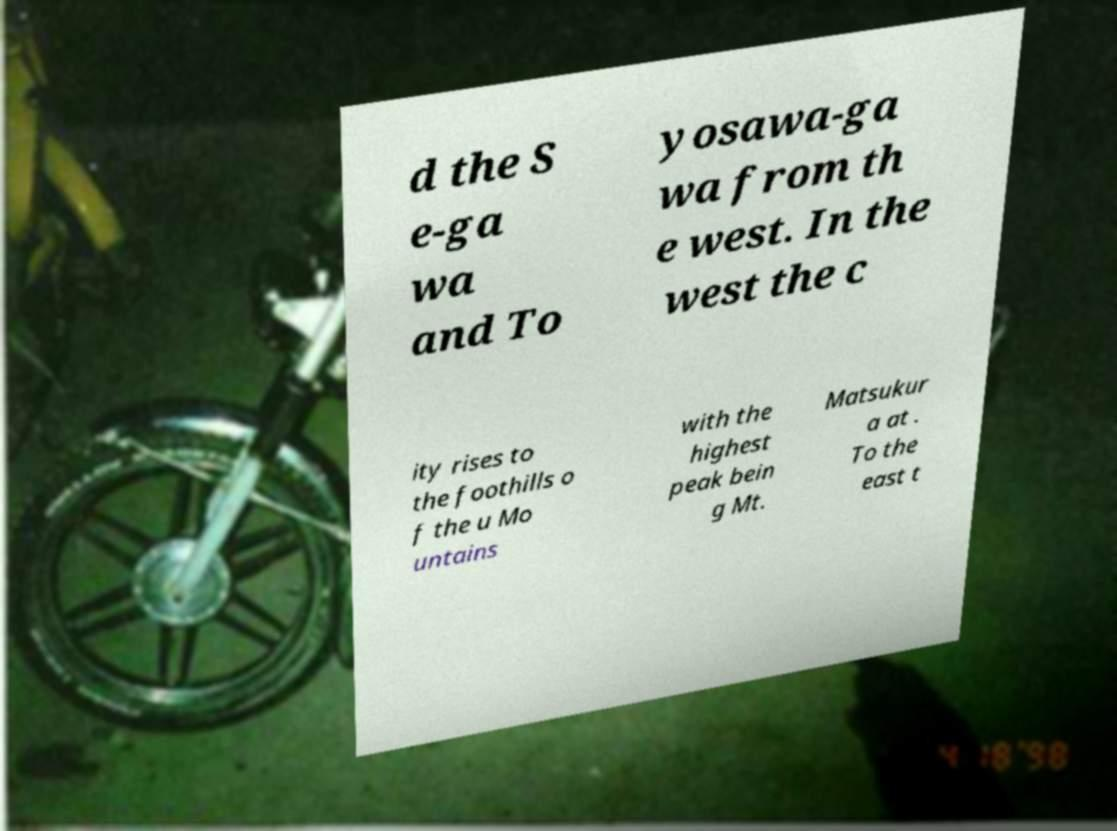Please identify and transcribe the text found in this image. d the S e-ga wa and To yosawa-ga wa from th e west. In the west the c ity rises to the foothills o f the u Mo untains with the highest peak bein g Mt. Matsukur a at . To the east t 